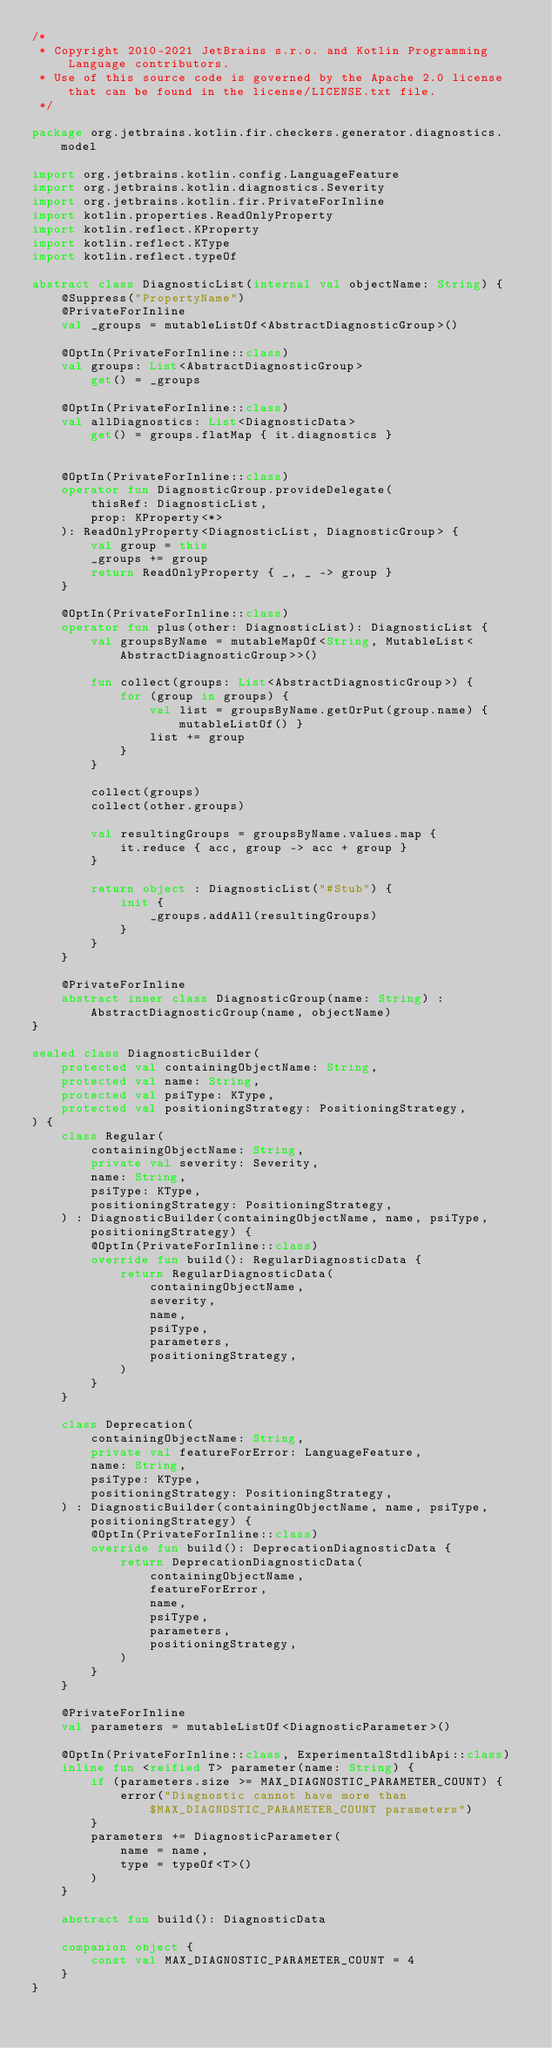<code> <loc_0><loc_0><loc_500><loc_500><_Kotlin_>/*
 * Copyright 2010-2021 JetBrains s.r.o. and Kotlin Programming Language contributors.
 * Use of this source code is governed by the Apache 2.0 license that can be found in the license/LICENSE.txt file.
 */

package org.jetbrains.kotlin.fir.checkers.generator.diagnostics.model

import org.jetbrains.kotlin.config.LanguageFeature
import org.jetbrains.kotlin.diagnostics.Severity
import org.jetbrains.kotlin.fir.PrivateForInline
import kotlin.properties.ReadOnlyProperty
import kotlin.reflect.KProperty
import kotlin.reflect.KType
import kotlin.reflect.typeOf

abstract class DiagnosticList(internal val objectName: String) {
    @Suppress("PropertyName")
    @PrivateForInline
    val _groups = mutableListOf<AbstractDiagnosticGroup>()

    @OptIn(PrivateForInline::class)
    val groups: List<AbstractDiagnosticGroup>
        get() = _groups

    @OptIn(PrivateForInline::class)
    val allDiagnostics: List<DiagnosticData>
        get() = groups.flatMap { it.diagnostics }


    @OptIn(PrivateForInline::class)
    operator fun DiagnosticGroup.provideDelegate(
        thisRef: DiagnosticList,
        prop: KProperty<*>
    ): ReadOnlyProperty<DiagnosticList, DiagnosticGroup> {
        val group = this
        _groups += group
        return ReadOnlyProperty { _, _ -> group }
    }

    @OptIn(PrivateForInline::class)
    operator fun plus(other: DiagnosticList): DiagnosticList {
        val groupsByName = mutableMapOf<String, MutableList<AbstractDiagnosticGroup>>()

        fun collect(groups: List<AbstractDiagnosticGroup>) {
            for (group in groups) {
                val list = groupsByName.getOrPut(group.name) { mutableListOf() }
                list += group
            }
        }

        collect(groups)
        collect(other.groups)

        val resultingGroups = groupsByName.values.map {
            it.reduce { acc, group -> acc + group }
        }

        return object : DiagnosticList("#Stub") {
            init {
                _groups.addAll(resultingGroups)
            }
        }
    }

    @PrivateForInline
    abstract inner class DiagnosticGroup(name: String) : AbstractDiagnosticGroup(name, objectName)
}

sealed class DiagnosticBuilder(
    protected val containingObjectName: String,
    protected val name: String,
    protected val psiType: KType,
    protected val positioningStrategy: PositioningStrategy,
) {
    class Regular(
        containingObjectName: String,
        private val severity: Severity,
        name: String,
        psiType: KType,
        positioningStrategy: PositioningStrategy,
    ) : DiagnosticBuilder(containingObjectName, name, psiType, positioningStrategy) {
        @OptIn(PrivateForInline::class)
        override fun build(): RegularDiagnosticData {
            return RegularDiagnosticData(
                containingObjectName,
                severity,
                name,
                psiType,
                parameters,
                positioningStrategy,
            )
        }
    }

    class Deprecation(
        containingObjectName: String,
        private val featureForError: LanguageFeature,
        name: String,
        psiType: KType,
        positioningStrategy: PositioningStrategy,
    ) : DiagnosticBuilder(containingObjectName, name, psiType, positioningStrategy) {
        @OptIn(PrivateForInline::class)
        override fun build(): DeprecationDiagnosticData {
            return DeprecationDiagnosticData(
                containingObjectName,
                featureForError,
                name,
                psiType,
                parameters,
                positioningStrategy,
            )
        }
    }

    @PrivateForInline
    val parameters = mutableListOf<DiagnosticParameter>()

    @OptIn(PrivateForInline::class, ExperimentalStdlibApi::class)
    inline fun <reified T> parameter(name: String) {
        if (parameters.size >= MAX_DIAGNOSTIC_PARAMETER_COUNT) {
            error("Diagnostic cannot have more than $MAX_DIAGNOSTIC_PARAMETER_COUNT parameters")
        }
        parameters += DiagnosticParameter(
            name = name,
            type = typeOf<T>()
        )
    }

    abstract fun build(): DiagnosticData

    companion object {
        const val MAX_DIAGNOSTIC_PARAMETER_COUNT = 4
    }
}
</code> 